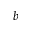<formula> <loc_0><loc_0><loc_500><loc_500>b</formula> 